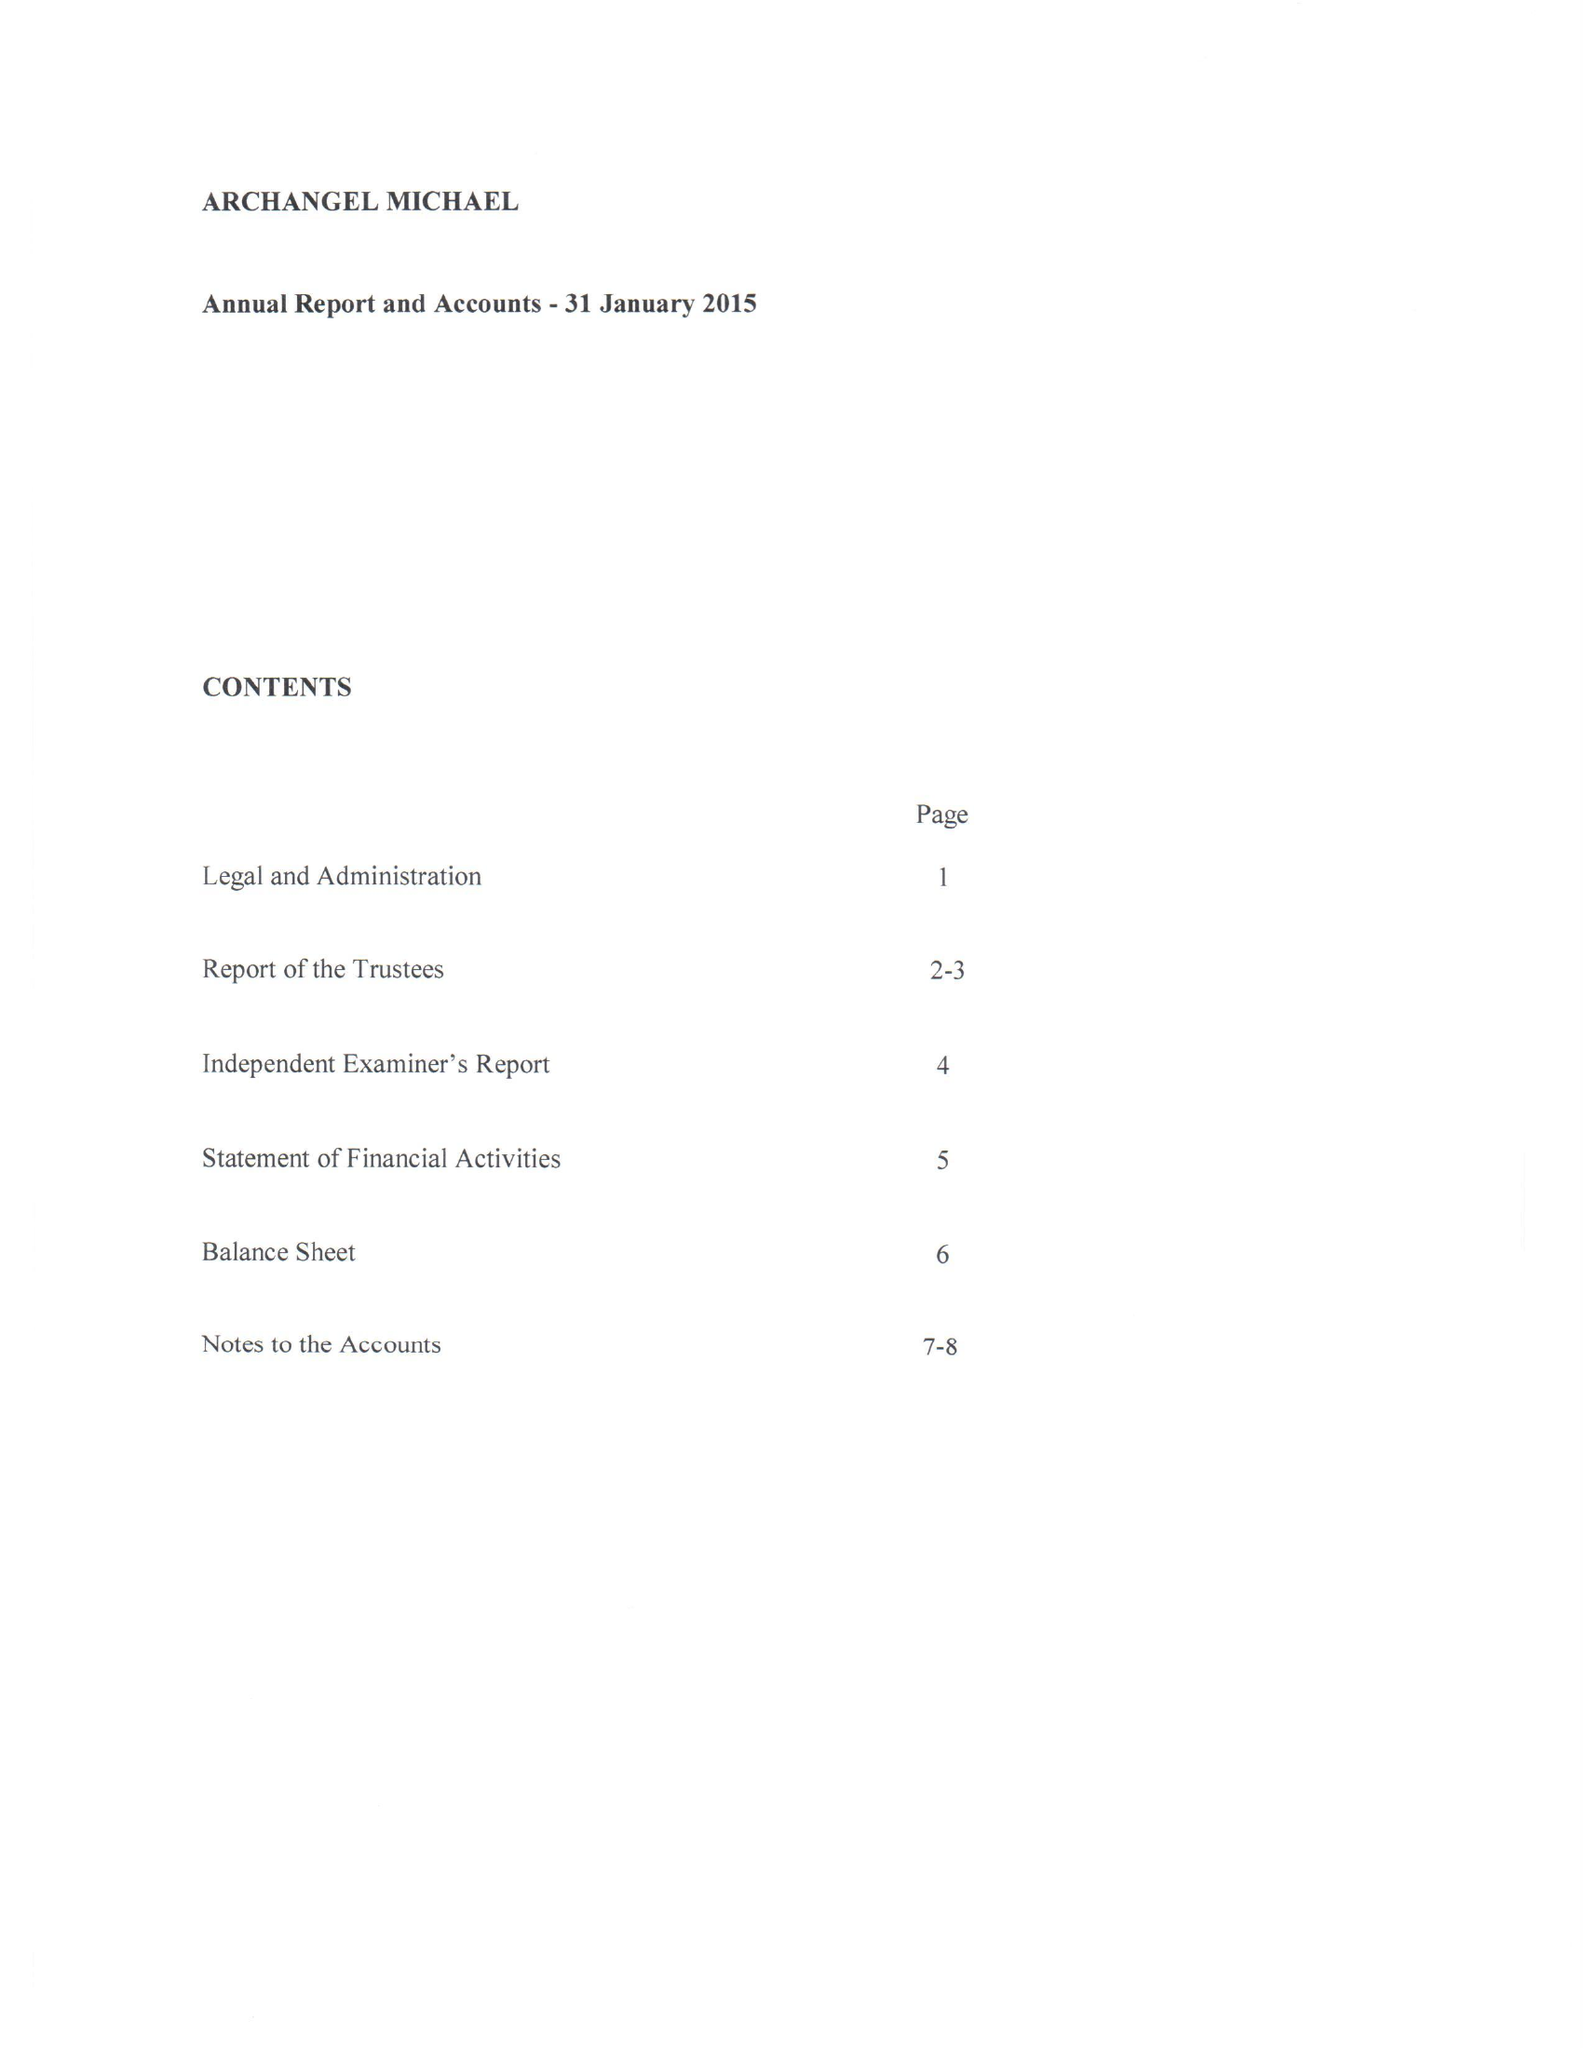What is the value for the address__post_town?
Answer the question using a single word or phrase. LONDON 